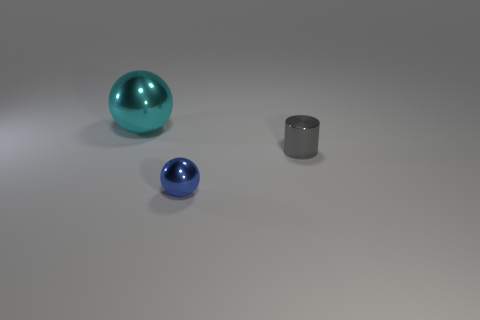Add 2 tiny cyan matte blocks. How many objects exist? 5 Subtract 1 cylinders. How many cylinders are left? 0 Subtract all yellow cylinders. How many yellow spheres are left? 0 Subtract all small gray objects. Subtract all small shiny cylinders. How many objects are left? 1 Add 2 cyan metallic objects. How many cyan metallic objects are left? 3 Add 2 tiny blue shiny spheres. How many tiny blue shiny spheres exist? 3 Subtract all cyan balls. How many balls are left? 1 Subtract 1 gray cylinders. How many objects are left? 2 Subtract all cylinders. How many objects are left? 2 Subtract all blue spheres. Subtract all purple cylinders. How many spheres are left? 1 